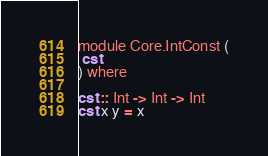<code> <loc_0><loc_0><loc_500><loc_500><_Haskell_>module Core.IntConst (
 cst
) where

cst :: Int -> Int -> Int
cst x y = x
</code> 